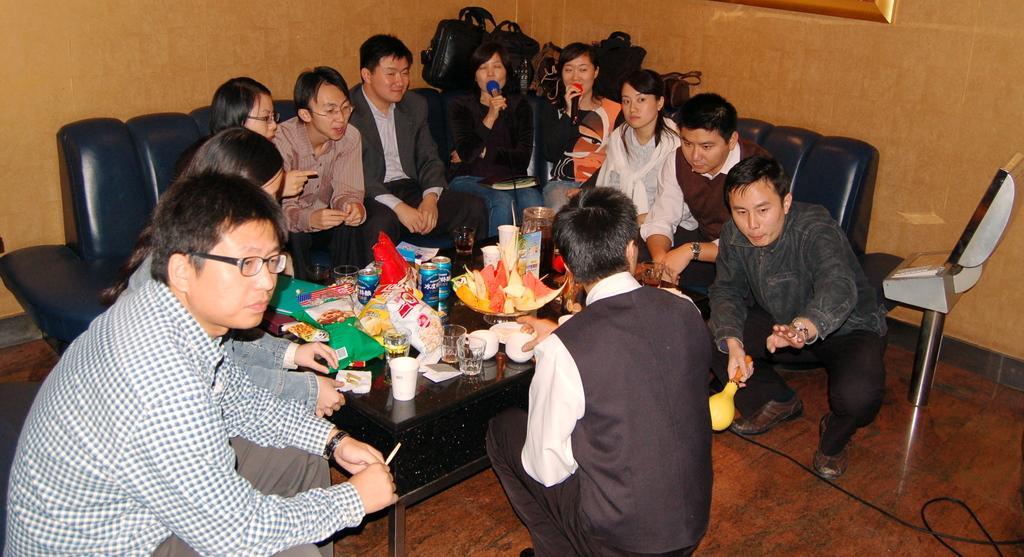Could you give a brief overview of what you see in this image? In this picture we can see a group of people where some are sitting on sofa and some are in squat position and in front of them there is table and on table we can see glass, plastic covers, bowl, tins, jar and in background we can see wall. 